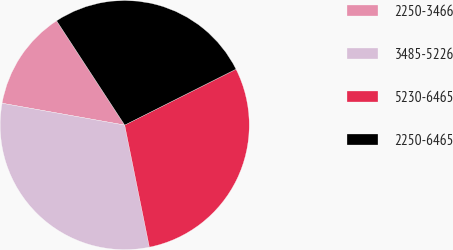<chart> <loc_0><loc_0><loc_500><loc_500><pie_chart><fcel>2250-3466<fcel>3485-5226<fcel>5230-6465<fcel>2250-6465<nl><fcel>12.99%<fcel>30.98%<fcel>29.23%<fcel>26.8%<nl></chart> 